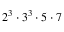Convert formula to latex. <formula><loc_0><loc_0><loc_500><loc_500>2 ^ { 3 } \cdot 3 ^ { 3 } \cdot 5 \cdot 7</formula> 